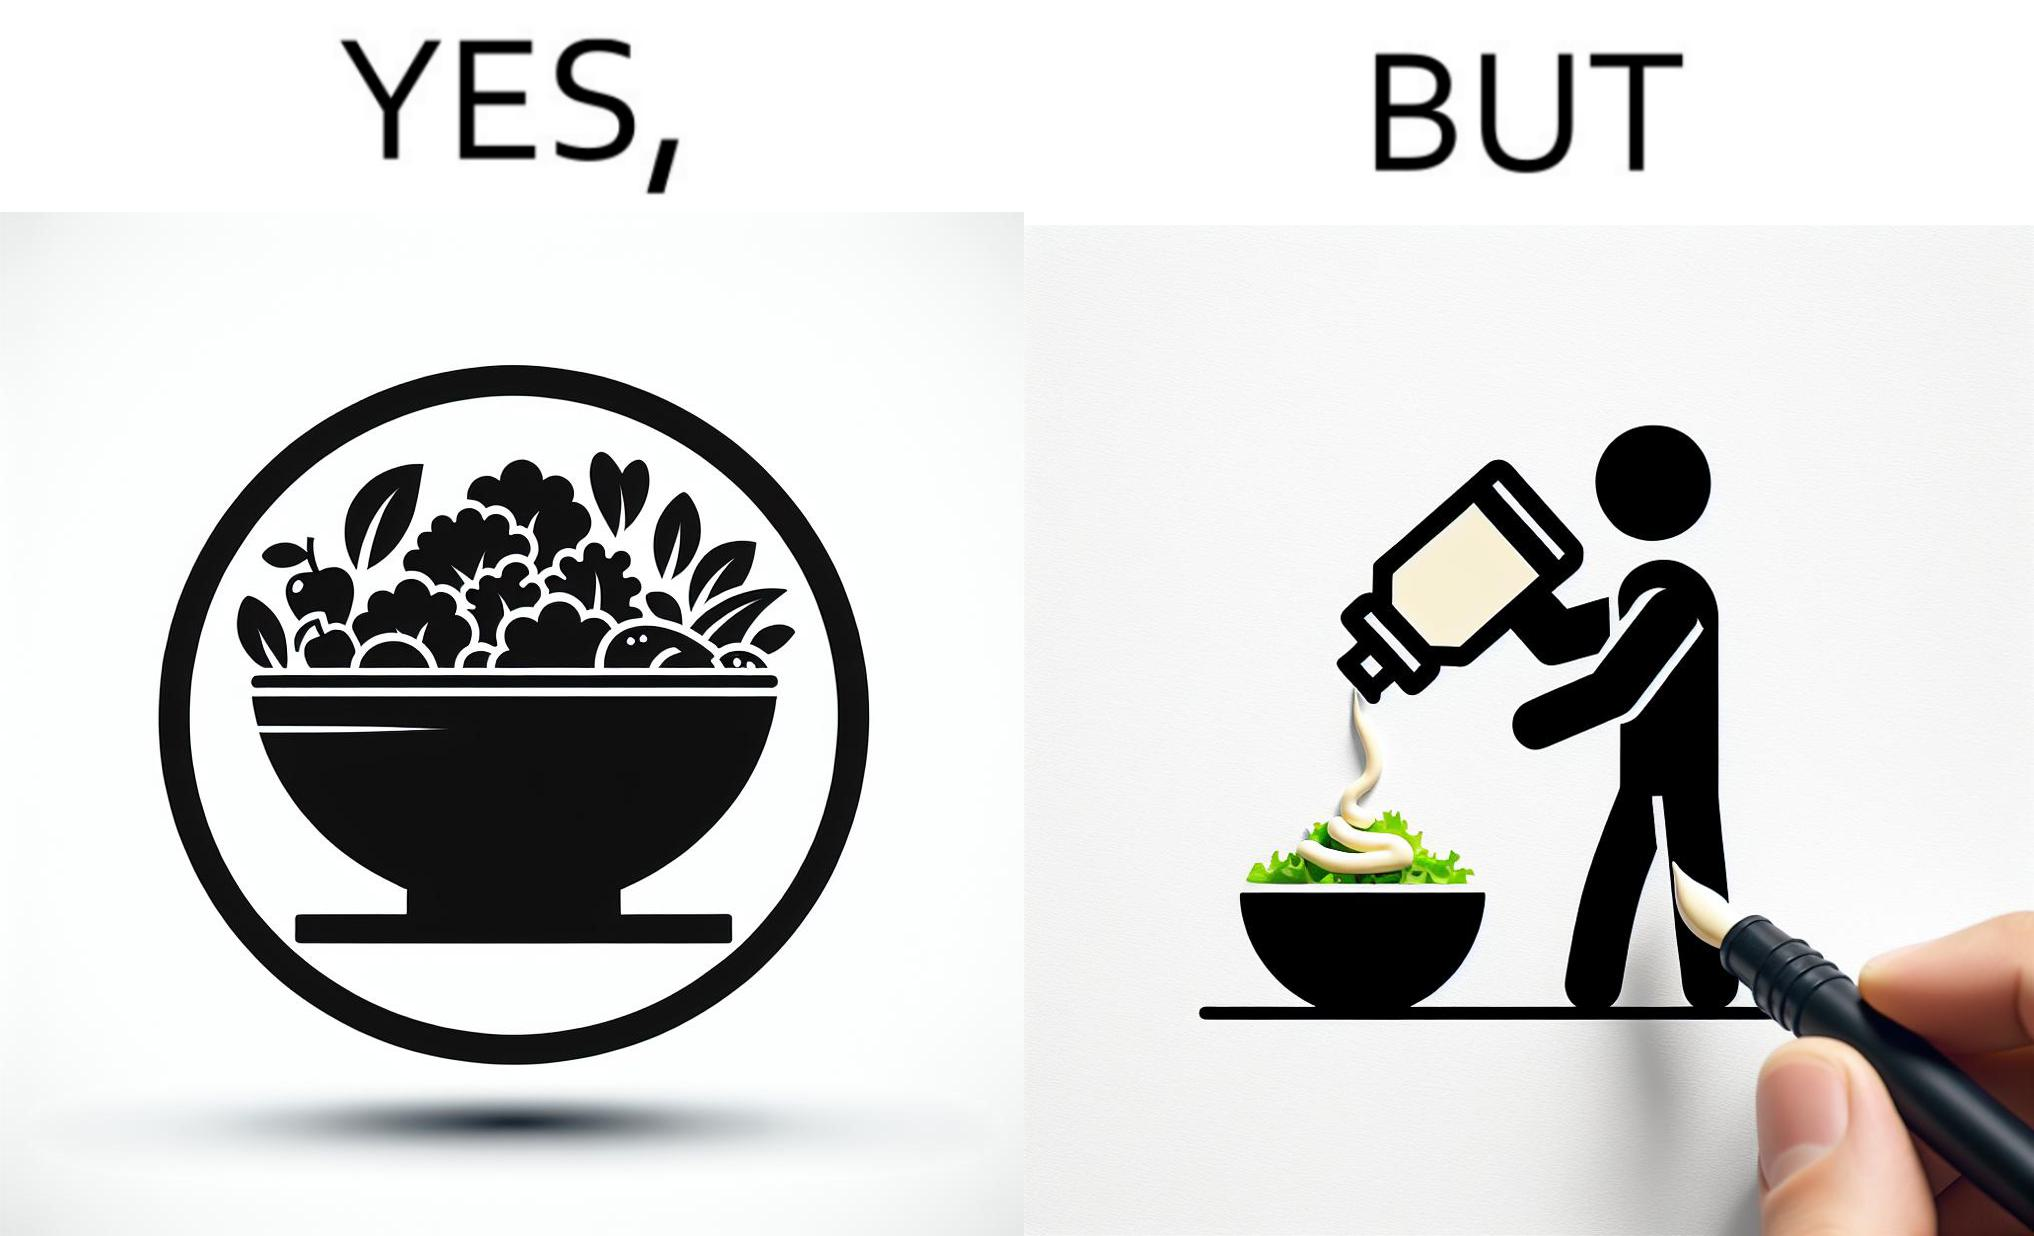Describe what you see in the left and right parts of this image. In the left part of the image: salad in a bowl In the right part of the image: pouring mayonnaise sauce on salad in a bowl 